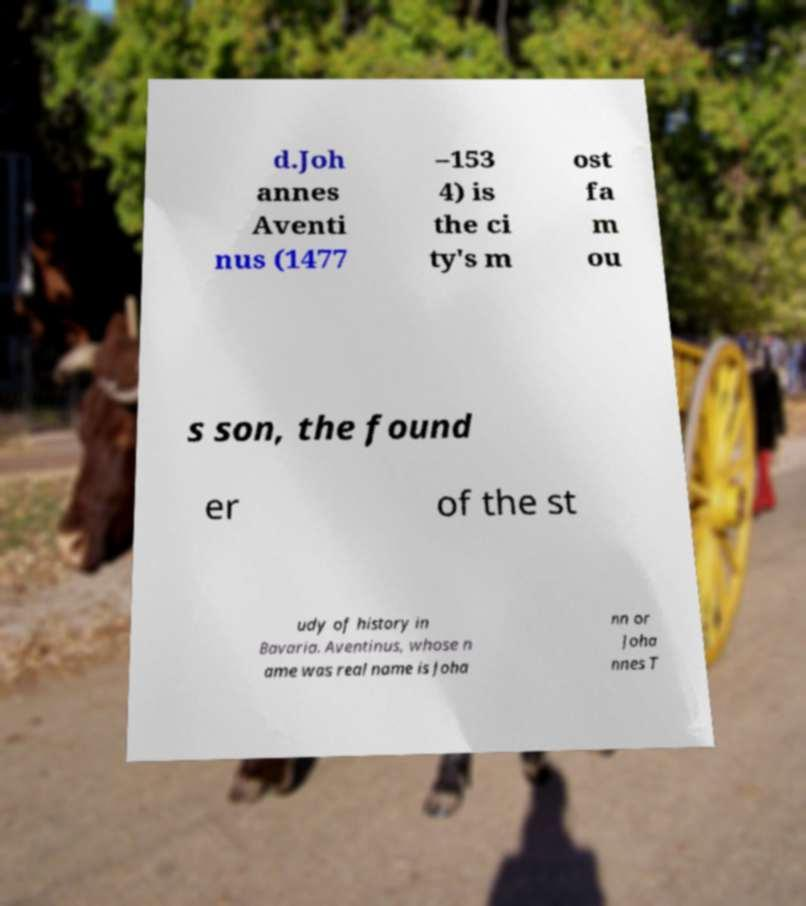Can you accurately transcribe the text from the provided image for me? d.Joh annes Aventi nus (1477 –153 4) is the ci ty's m ost fa m ou s son, the found er of the st udy of history in Bavaria. Aventinus, whose n ame was real name is Joha nn or Joha nnes T 